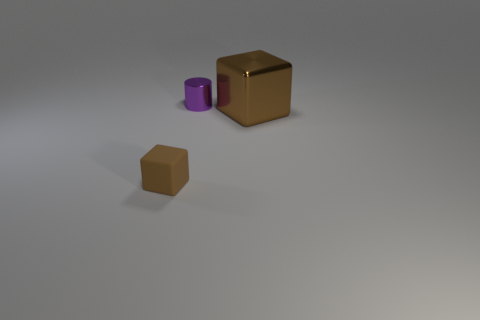Subtract all cubes. How many objects are left? 1 Add 2 shiny cubes. How many objects exist? 5 Subtract 2 cubes. How many cubes are left? 0 Subtract 0 brown spheres. How many objects are left? 3 Subtract all cyan cubes. Subtract all red cylinders. How many cubes are left? 2 Subtract all yellow rubber objects. Subtract all tiny brown rubber objects. How many objects are left? 2 Add 1 brown metal blocks. How many brown metal blocks are left? 2 Add 3 rubber things. How many rubber things exist? 4 